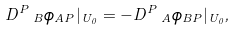Convert formula to latex. <formula><loc_0><loc_0><loc_500><loc_500>D ^ { P } \, _ { B } \phi _ { A P } | _ { U _ { 0 } } = - D ^ { P } \, _ { A } \phi _ { B P } | _ { U _ { 0 } } ,</formula> 